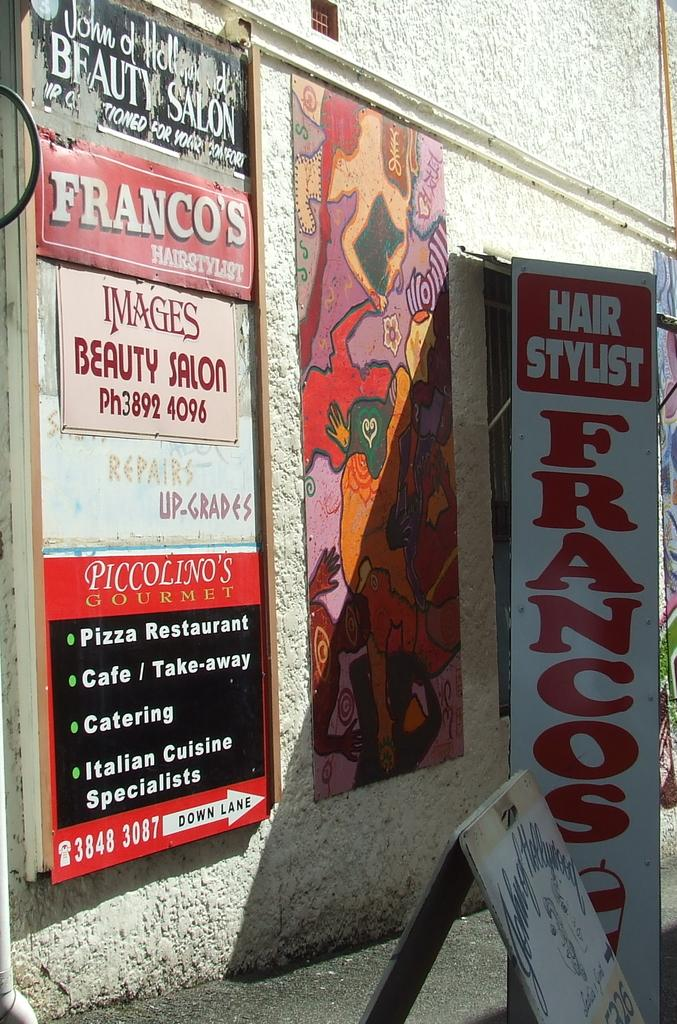Provide a one-sentence caption for the provided image. The side of a building that is advertising Franco's beauty Salon. 